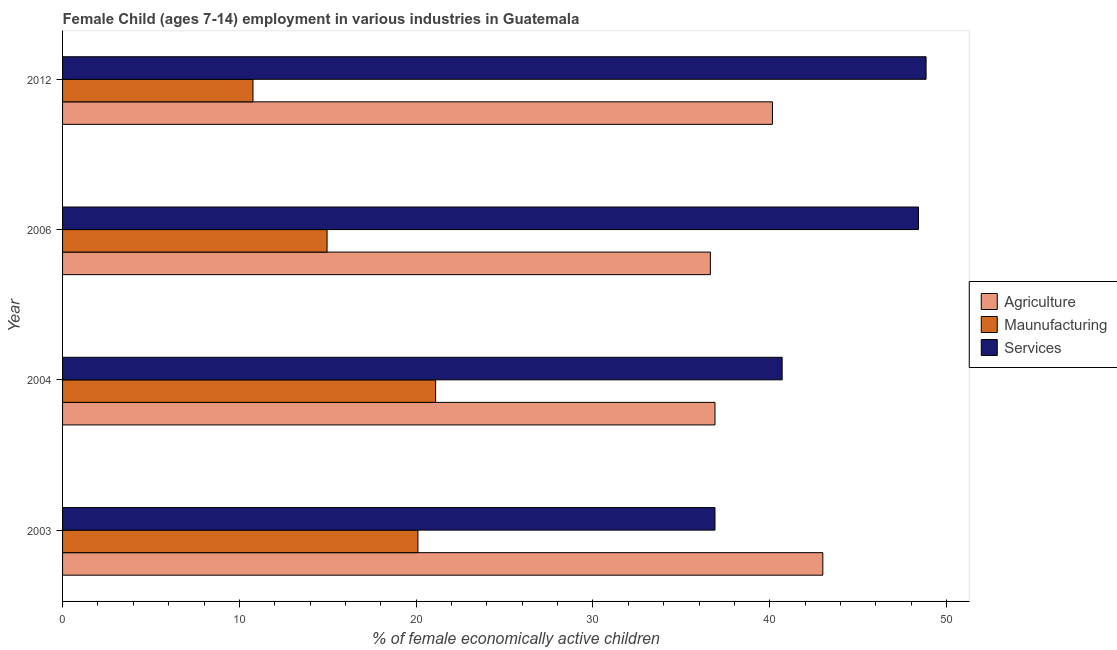How many different coloured bars are there?
Provide a short and direct response. 3. Are the number of bars on each tick of the Y-axis equal?
Ensure brevity in your answer.  Yes. How many bars are there on the 3rd tick from the top?
Provide a succinct answer. 3. What is the percentage of economically active children in services in 2004?
Offer a very short reply. 40.7. Across all years, what is the maximum percentage of economically active children in services?
Offer a terse response. 48.84. Across all years, what is the minimum percentage of economically active children in agriculture?
Make the answer very short. 36.64. In which year was the percentage of economically active children in manufacturing minimum?
Your response must be concise. 2012. What is the total percentage of economically active children in manufacturing in the graph?
Offer a very short reply. 66.93. What is the difference between the percentage of economically active children in agriculture in 2003 and that in 2006?
Make the answer very short. 6.36. What is the difference between the percentage of economically active children in agriculture in 2006 and the percentage of economically active children in services in 2012?
Ensure brevity in your answer.  -12.2. What is the average percentage of economically active children in services per year?
Make the answer very short. 43.71. In the year 2004, what is the difference between the percentage of economically active children in services and percentage of economically active children in agriculture?
Your answer should be very brief. 3.8. What is the ratio of the percentage of economically active children in services in 2003 to that in 2006?
Offer a terse response. 0.76. Is the percentage of economically active children in services in 2006 less than that in 2012?
Your answer should be compact. Yes. What is the difference between the highest and the lowest percentage of economically active children in services?
Give a very brief answer. 11.94. What does the 3rd bar from the top in 2003 represents?
Give a very brief answer. Agriculture. What does the 1st bar from the bottom in 2012 represents?
Offer a terse response. Agriculture. Is it the case that in every year, the sum of the percentage of economically active children in agriculture and percentage of economically active children in manufacturing is greater than the percentage of economically active children in services?
Your response must be concise. Yes. How many bars are there?
Ensure brevity in your answer.  12. Are all the bars in the graph horizontal?
Give a very brief answer. Yes. How many years are there in the graph?
Offer a very short reply. 4. What is the difference between two consecutive major ticks on the X-axis?
Give a very brief answer. 10. Are the values on the major ticks of X-axis written in scientific E-notation?
Provide a succinct answer. No. How are the legend labels stacked?
Offer a terse response. Vertical. What is the title of the graph?
Keep it short and to the point. Female Child (ages 7-14) employment in various industries in Guatemala. Does "Domestic" appear as one of the legend labels in the graph?
Your answer should be very brief. No. What is the label or title of the X-axis?
Provide a succinct answer. % of female economically active children. What is the % of female economically active children of Agriculture in 2003?
Provide a short and direct response. 43. What is the % of female economically active children of Maunufacturing in 2003?
Your answer should be very brief. 20.1. What is the % of female economically active children in Services in 2003?
Make the answer very short. 36.9. What is the % of female economically active children in Agriculture in 2004?
Keep it short and to the point. 36.9. What is the % of female economically active children of Maunufacturing in 2004?
Ensure brevity in your answer.  21.1. What is the % of female economically active children of Services in 2004?
Keep it short and to the point. 40.7. What is the % of female economically active children of Agriculture in 2006?
Provide a short and direct response. 36.64. What is the % of female economically active children of Maunufacturing in 2006?
Ensure brevity in your answer.  14.96. What is the % of female economically active children of Services in 2006?
Provide a succinct answer. 48.41. What is the % of female economically active children of Agriculture in 2012?
Your answer should be compact. 40.15. What is the % of female economically active children of Maunufacturing in 2012?
Your answer should be compact. 10.77. What is the % of female economically active children of Services in 2012?
Provide a succinct answer. 48.84. Across all years, what is the maximum % of female economically active children in Agriculture?
Offer a very short reply. 43. Across all years, what is the maximum % of female economically active children in Maunufacturing?
Give a very brief answer. 21.1. Across all years, what is the maximum % of female economically active children of Services?
Ensure brevity in your answer.  48.84. Across all years, what is the minimum % of female economically active children in Agriculture?
Provide a succinct answer. 36.64. Across all years, what is the minimum % of female economically active children of Maunufacturing?
Your response must be concise. 10.77. Across all years, what is the minimum % of female economically active children of Services?
Keep it short and to the point. 36.9. What is the total % of female economically active children in Agriculture in the graph?
Your answer should be very brief. 156.69. What is the total % of female economically active children in Maunufacturing in the graph?
Provide a succinct answer. 66.93. What is the total % of female economically active children of Services in the graph?
Ensure brevity in your answer.  174.85. What is the difference between the % of female economically active children in Agriculture in 2003 and that in 2004?
Your response must be concise. 6.1. What is the difference between the % of female economically active children in Services in 2003 and that in 2004?
Offer a very short reply. -3.8. What is the difference between the % of female economically active children of Agriculture in 2003 and that in 2006?
Your answer should be very brief. 6.36. What is the difference between the % of female economically active children in Maunufacturing in 2003 and that in 2006?
Give a very brief answer. 5.14. What is the difference between the % of female economically active children in Services in 2003 and that in 2006?
Offer a very short reply. -11.51. What is the difference between the % of female economically active children of Agriculture in 2003 and that in 2012?
Ensure brevity in your answer.  2.85. What is the difference between the % of female economically active children in Maunufacturing in 2003 and that in 2012?
Offer a very short reply. 9.33. What is the difference between the % of female economically active children of Services in 2003 and that in 2012?
Offer a very short reply. -11.94. What is the difference between the % of female economically active children in Agriculture in 2004 and that in 2006?
Keep it short and to the point. 0.26. What is the difference between the % of female economically active children of Maunufacturing in 2004 and that in 2006?
Offer a very short reply. 6.14. What is the difference between the % of female economically active children in Services in 2004 and that in 2006?
Your response must be concise. -7.71. What is the difference between the % of female economically active children in Agriculture in 2004 and that in 2012?
Make the answer very short. -3.25. What is the difference between the % of female economically active children of Maunufacturing in 2004 and that in 2012?
Your response must be concise. 10.33. What is the difference between the % of female economically active children of Services in 2004 and that in 2012?
Keep it short and to the point. -8.14. What is the difference between the % of female economically active children of Agriculture in 2006 and that in 2012?
Offer a terse response. -3.51. What is the difference between the % of female economically active children in Maunufacturing in 2006 and that in 2012?
Offer a very short reply. 4.19. What is the difference between the % of female economically active children in Services in 2006 and that in 2012?
Offer a very short reply. -0.43. What is the difference between the % of female economically active children in Agriculture in 2003 and the % of female economically active children in Maunufacturing in 2004?
Provide a succinct answer. 21.9. What is the difference between the % of female economically active children of Agriculture in 2003 and the % of female economically active children of Services in 2004?
Offer a very short reply. 2.3. What is the difference between the % of female economically active children in Maunufacturing in 2003 and the % of female economically active children in Services in 2004?
Offer a terse response. -20.6. What is the difference between the % of female economically active children in Agriculture in 2003 and the % of female economically active children in Maunufacturing in 2006?
Keep it short and to the point. 28.04. What is the difference between the % of female economically active children of Agriculture in 2003 and the % of female economically active children of Services in 2006?
Your answer should be very brief. -5.41. What is the difference between the % of female economically active children of Maunufacturing in 2003 and the % of female economically active children of Services in 2006?
Offer a very short reply. -28.31. What is the difference between the % of female economically active children in Agriculture in 2003 and the % of female economically active children in Maunufacturing in 2012?
Give a very brief answer. 32.23. What is the difference between the % of female economically active children of Agriculture in 2003 and the % of female economically active children of Services in 2012?
Ensure brevity in your answer.  -5.84. What is the difference between the % of female economically active children in Maunufacturing in 2003 and the % of female economically active children in Services in 2012?
Offer a very short reply. -28.74. What is the difference between the % of female economically active children in Agriculture in 2004 and the % of female economically active children in Maunufacturing in 2006?
Provide a short and direct response. 21.94. What is the difference between the % of female economically active children of Agriculture in 2004 and the % of female economically active children of Services in 2006?
Make the answer very short. -11.51. What is the difference between the % of female economically active children in Maunufacturing in 2004 and the % of female economically active children in Services in 2006?
Ensure brevity in your answer.  -27.31. What is the difference between the % of female economically active children of Agriculture in 2004 and the % of female economically active children of Maunufacturing in 2012?
Offer a very short reply. 26.13. What is the difference between the % of female economically active children of Agriculture in 2004 and the % of female economically active children of Services in 2012?
Ensure brevity in your answer.  -11.94. What is the difference between the % of female economically active children in Maunufacturing in 2004 and the % of female economically active children in Services in 2012?
Your response must be concise. -27.74. What is the difference between the % of female economically active children of Agriculture in 2006 and the % of female economically active children of Maunufacturing in 2012?
Your answer should be very brief. 25.87. What is the difference between the % of female economically active children of Agriculture in 2006 and the % of female economically active children of Services in 2012?
Provide a short and direct response. -12.2. What is the difference between the % of female economically active children in Maunufacturing in 2006 and the % of female economically active children in Services in 2012?
Give a very brief answer. -33.88. What is the average % of female economically active children of Agriculture per year?
Your answer should be very brief. 39.17. What is the average % of female economically active children of Maunufacturing per year?
Your answer should be very brief. 16.73. What is the average % of female economically active children in Services per year?
Provide a short and direct response. 43.71. In the year 2003, what is the difference between the % of female economically active children of Agriculture and % of female economically active children of Maunufacturing?
Make the answer very short. 22.9. In the year 2003, what is the difference between the % of female economically active children in Maunufacturing and % of female economically active children in Services?
Your response must be concise. -16.8. In the year 2004, what is the difference between the % of female economically active children in Agriculture and % of female economically active children in Maunufacturing?
Ensure brevity in your answer.  15.8. In the year 2004, what is the difference between the % of female economically active children of Maunufacturing and % of female economically active children of Services?
Your answer should be compact. -19.6. In the year 2006, what is the difference between the % of female economically active children in Agriculture and % of female economically active children in Maunufacturing?
Make the answer very short. 21.68. In the year 2006, what is the difference between the % of female economically active children of Agriculture and % of female economically active children of Services?
Offer a terse response. -11.77. In the year 2006, what is the difference between the % of female economically active children of Maunufacturing and % of female economically active children of Services?
Ensure brevity in your answer.  -33.45. In the year 2012, what is the difference between the % of female economically active children in Agriculture and % of female economically active children in Maunufacturing?
Offer a very short reply. 29.38. In the year 2012, what is the difference between the % of female economically active children in Agriculture and % of female economically active children in Services?
Your response must be concise. -8.69. In the year 2012, what is the difference between the % of female economically active children of Maunufacturing and % of female economically active children of Services?
Offer a terse response. -38.07. What is the ratio of the % of female economically active children in Agriculture in 2003 to that in 2004?
Ensure brevity in your answer.  1.17. What is the ratio of the % of female economically active children in Maunufacturing in 2003 to that in 2004?
Provide a short and direct response. 0.95. What is the ratio of the % of female economically active children in Services in 2003 to that in 2004?
Offer a terse response. 0.91. What is the ratio of the % of female economically active children of Agriculture in 2003 to that in 2006?
Provide a short and direct response. 1.17. What is the ratio of the % of female economically active children in Maunufacturing in 2003 to that in 2006?
Offer a very short reply. 1.34. What is the ratio of the % of female economically active children in Services in 2003 to that in 2006?
Your answer should be compact. 0.76. What is the ratio of the % of female economically active children in Agriculture in 2003 to that in 2012?
Give a very brief answer. 1.07. What is the ratio of the % of female economically active children in Maunufacturing in 2003 to that in 2012?
Provide a succinct answer. 1.87. What is the ratio of the % of female economically active children of Services in 2003 to that in 2012?
Offer a very short reply. 0.76. What is the ratio of the % of female economically active children in Agriculture in 2004 to that in 2006?
Ensure brevity in your answer.  1.01. What is the ratio of the % of female economically active children of Maunufacturing in 2004 to that in 2006?
Provide a succinct answer. 1.41. What is the ratio of the % of female economically active children in Services in 2004 to that in 2006?
Provide a short and direct response. 0.84. What is the ratio of the % of female economically active children in Agriculture in 2004 to that in 2012?
Keep it short and to the point. 0.92. What is the ratio of the % of female economically active children in Maunufacturing in 2004 to that in 2012?
Provide a short and direct response. 1.96. What is the ratio of the % of female economically active children of Agriculture in 2006 to that in 2012?
Give a very brief answer. 0.91. What is the ratio of the % of female economically active children in Maunufacturing in 2006 to that in 2012?
Your answer should be compact. 1.39. What is the ratio of the % of female economically active children of Services in 2006 to that in 2012?
Provide a succinct answer. 0.99. What is the difference between the highest and the second highest % of female economically active children of Agriculture?
Offer a very short reply. 2.85. What is the difference between the highest and the second highest % of female economically active children of Services?
Your response must be concise. 0.43. What is the difference between the highest and the lowest % of female economically active children of Agriculture?
Offer a very short reply. 6.36. What is the difference between the highest and the lowest % of female economically active children of Maunufacturing?
Offer a very short reply. 10.33. What is the difference between the highest and the lowest % of female economically active children in Services?
Provide a short and direct response. 11.94. 